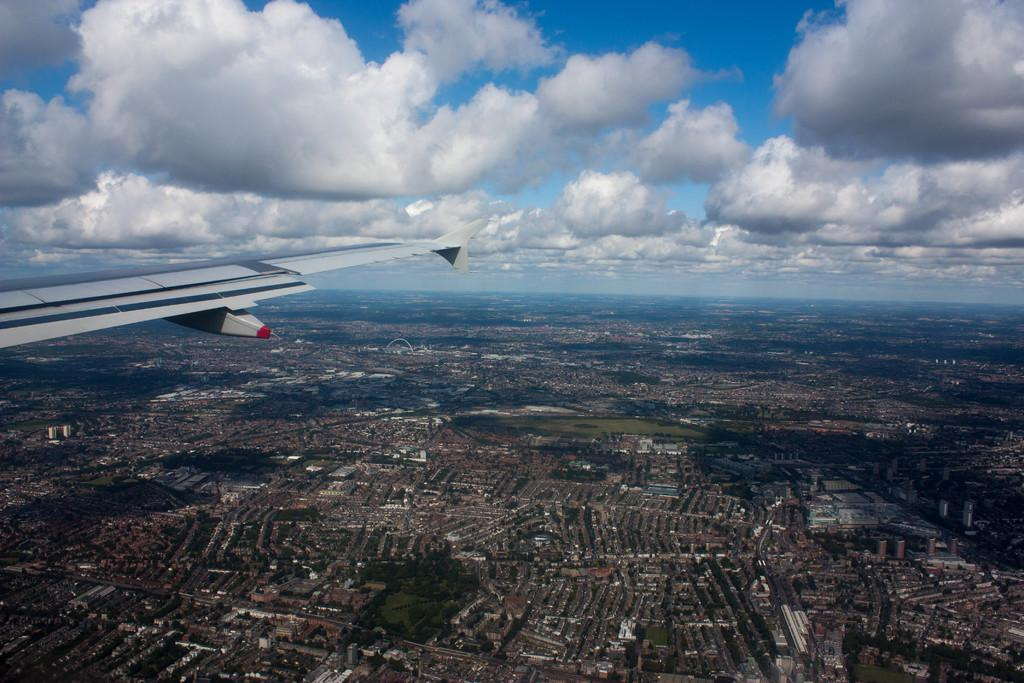What is the main subject of the image? The image shows a view of the city from a plane window. What part of the plane can be seen in the image? There is a white-colored plane wing visible in the image. What type of structures are visible on the ground in the image? There are many buildings on the ground in the image. Where is the meeting taking place in the image? There is no meeting taking place in the image; it is a view of the city from a plane window. Can you see a crown on top of any of the buildings in the image? There is no crown visible on any of the buildings in the image. 